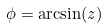Convert formula to latex. <formula><loc_0><loc_0><loc_500><loc_500>\phi = \arcsin ( z )</formula> 